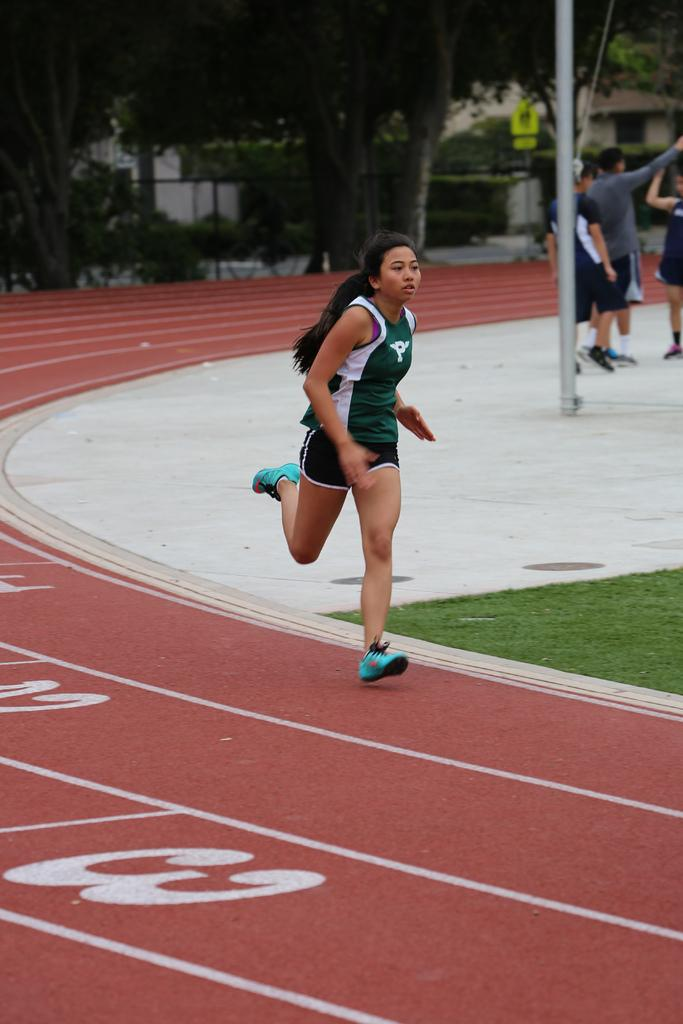<image>
Render a clear and concise summary of the photo. A girl wearing a green uniform races past the numbers 2 and 3 on the track 